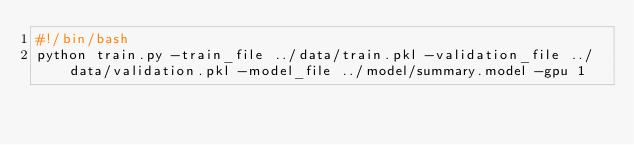<code> <loc_0><loc_0><loc_500><loc_500><_Bash_>#!/bin/bash
python train.py -train_file ../data/train.pkl -validation_file ../data/validation.pkl -model_file ../model/summary.model -gpu 1
</code> 